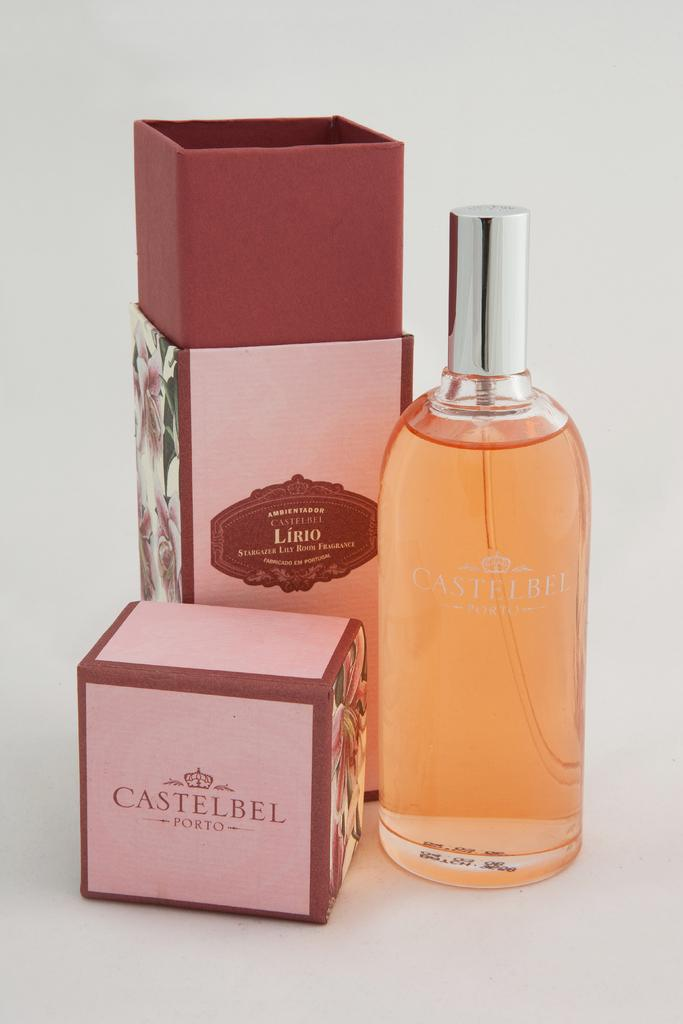<image>
Describe the image concisely. Boxes and bottle that say castelbel Porto on them. 